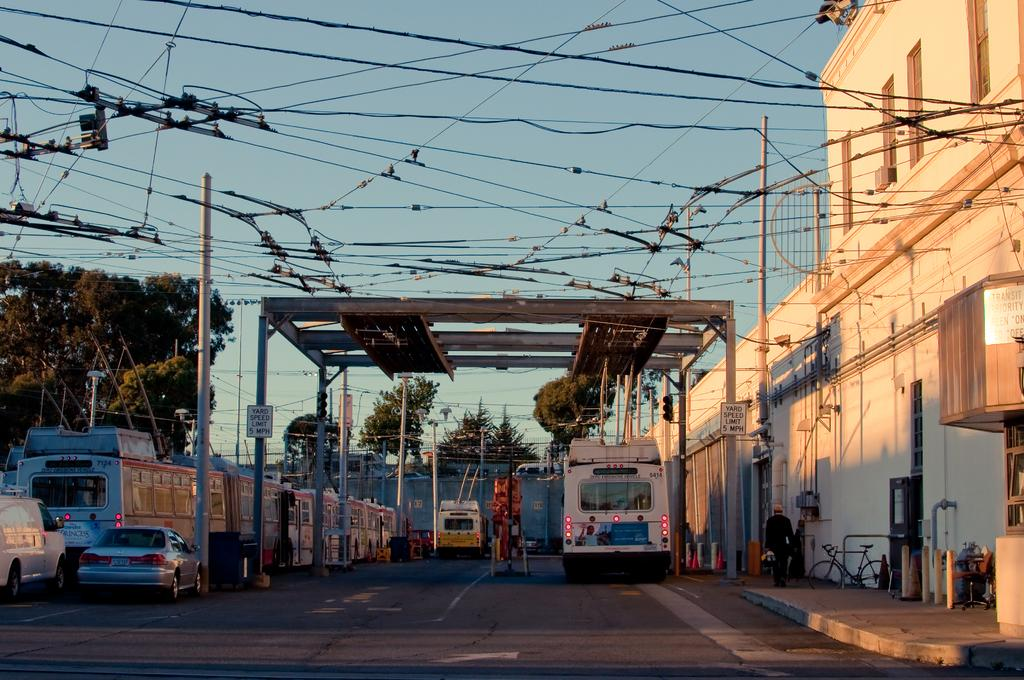What can be seen in the foreground of the image? There are wires in the foreground of the image. What is visible in the background of the image? Vehicles, poles, trees, a person, a bicycle, and the sky are visible in the background of the image. Where is the building located in the image? The building is on the right side of the image. Can you tell me how many fish are swimming in the sky in the image? There are no fish present in the image, and the sky is not a body of water where fish would swim. 